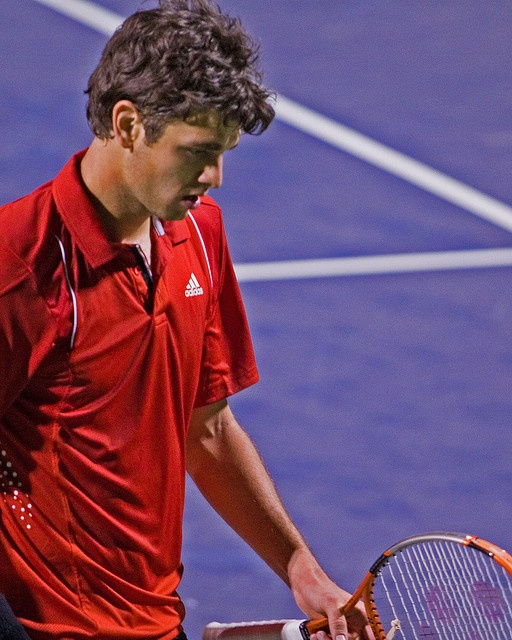Describe the objects in this image and their specific colors. I can see people in purple, maroon, brown, black, and red tones and tennis racket in purple, darkgray, and maroon tones in this image. 